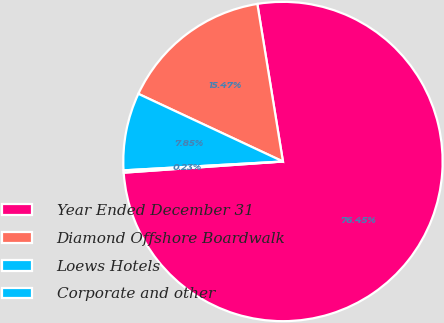<chart> <loc_0><loc_0><loc_500><loc_500><pie_chart><fcel>Year Ended December 31<fcel>Diamond Offshore Boardwalk<fcel>Loews Hotels<fcel>Corporate and other<nl><fcel>76.45%<fcel>15.47%<fcel>7.85%<fcel>0.23%<nl></chart> 